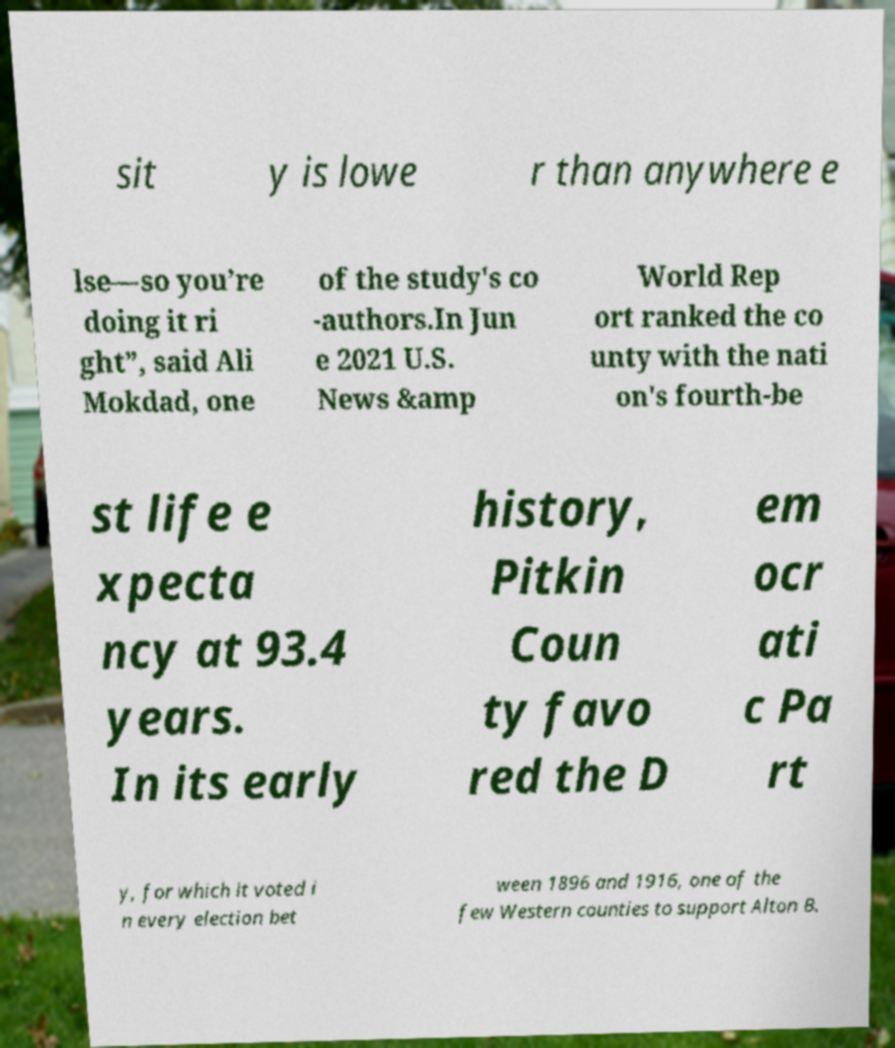Please identify and transcribe the text found in this image. sit y is lowe r than anywhere e lse—so you’re doing it ri ght”, said Ali Mokdad, one of the study's co -authors.In Jun e 2021 U.S. News &amp World Rep ort ranked the co unty with the nati on's fourth-be st life e xpecta ncy at 93.4 years. In its early history, Pitkin Coun ty favo red the D em ocr ati c Pa rt y, for which it voted i n every election bet ween 1896 and 1916, one of the few Western counties to support Alton B. 